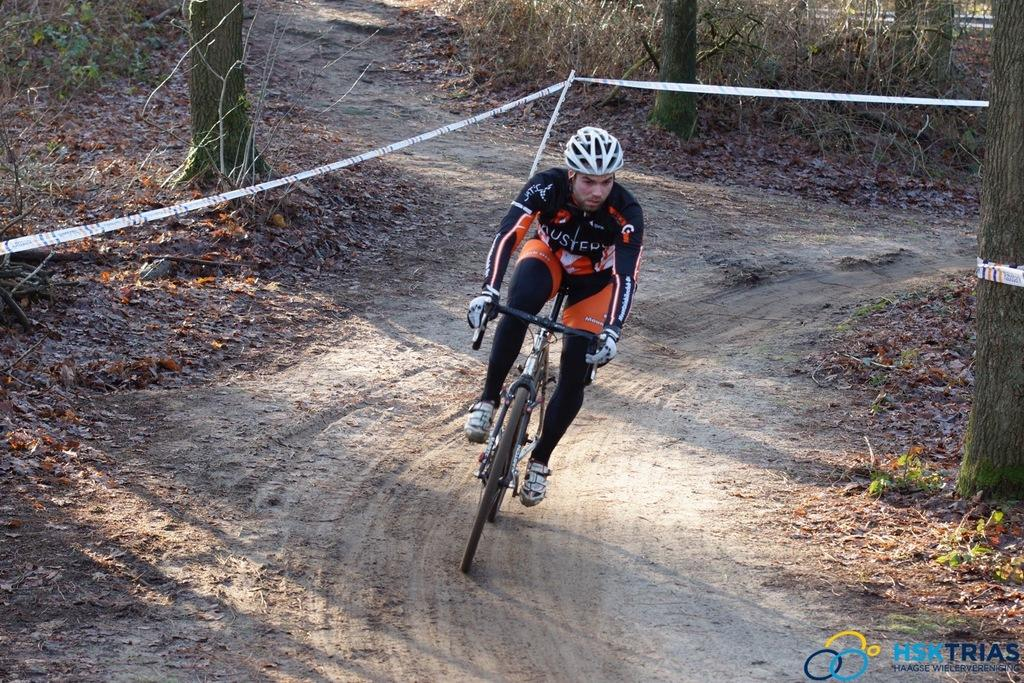What is the person in the image doing? There is a person riding a bicycle in the image. What safety precaution is the person taking while riding the bicycle? The person is wearing a helmet. What can be seen in the background of the image? There are trees, plants, and shredded leaves in the background of the image. What is visible beneath the person and bicycle? The ground is visible in the image. Can you see any fairies flying around the person riding the bicycle in the image? There are no fairies present in the image. Is there a swing visible in the background of the image? There is no swing present in the image. 